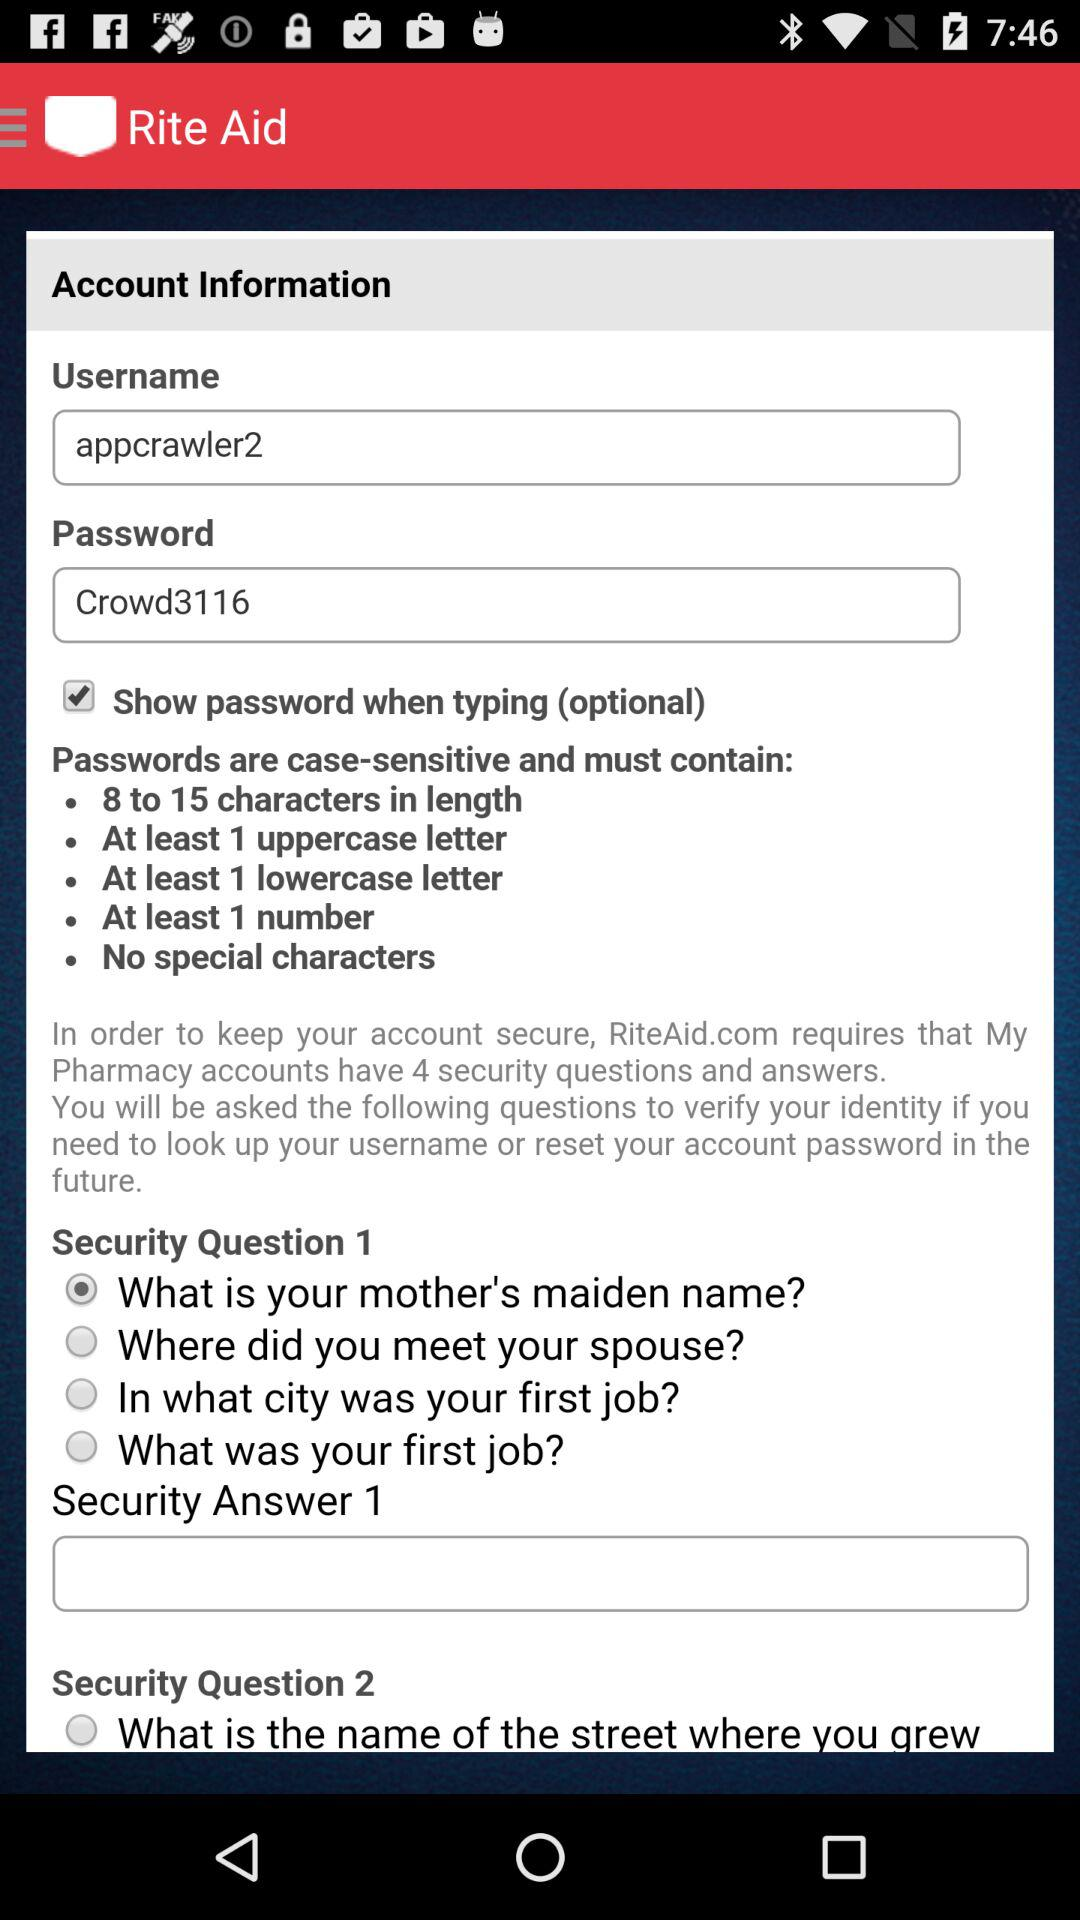What is the username? The username is "appcrawler2". 